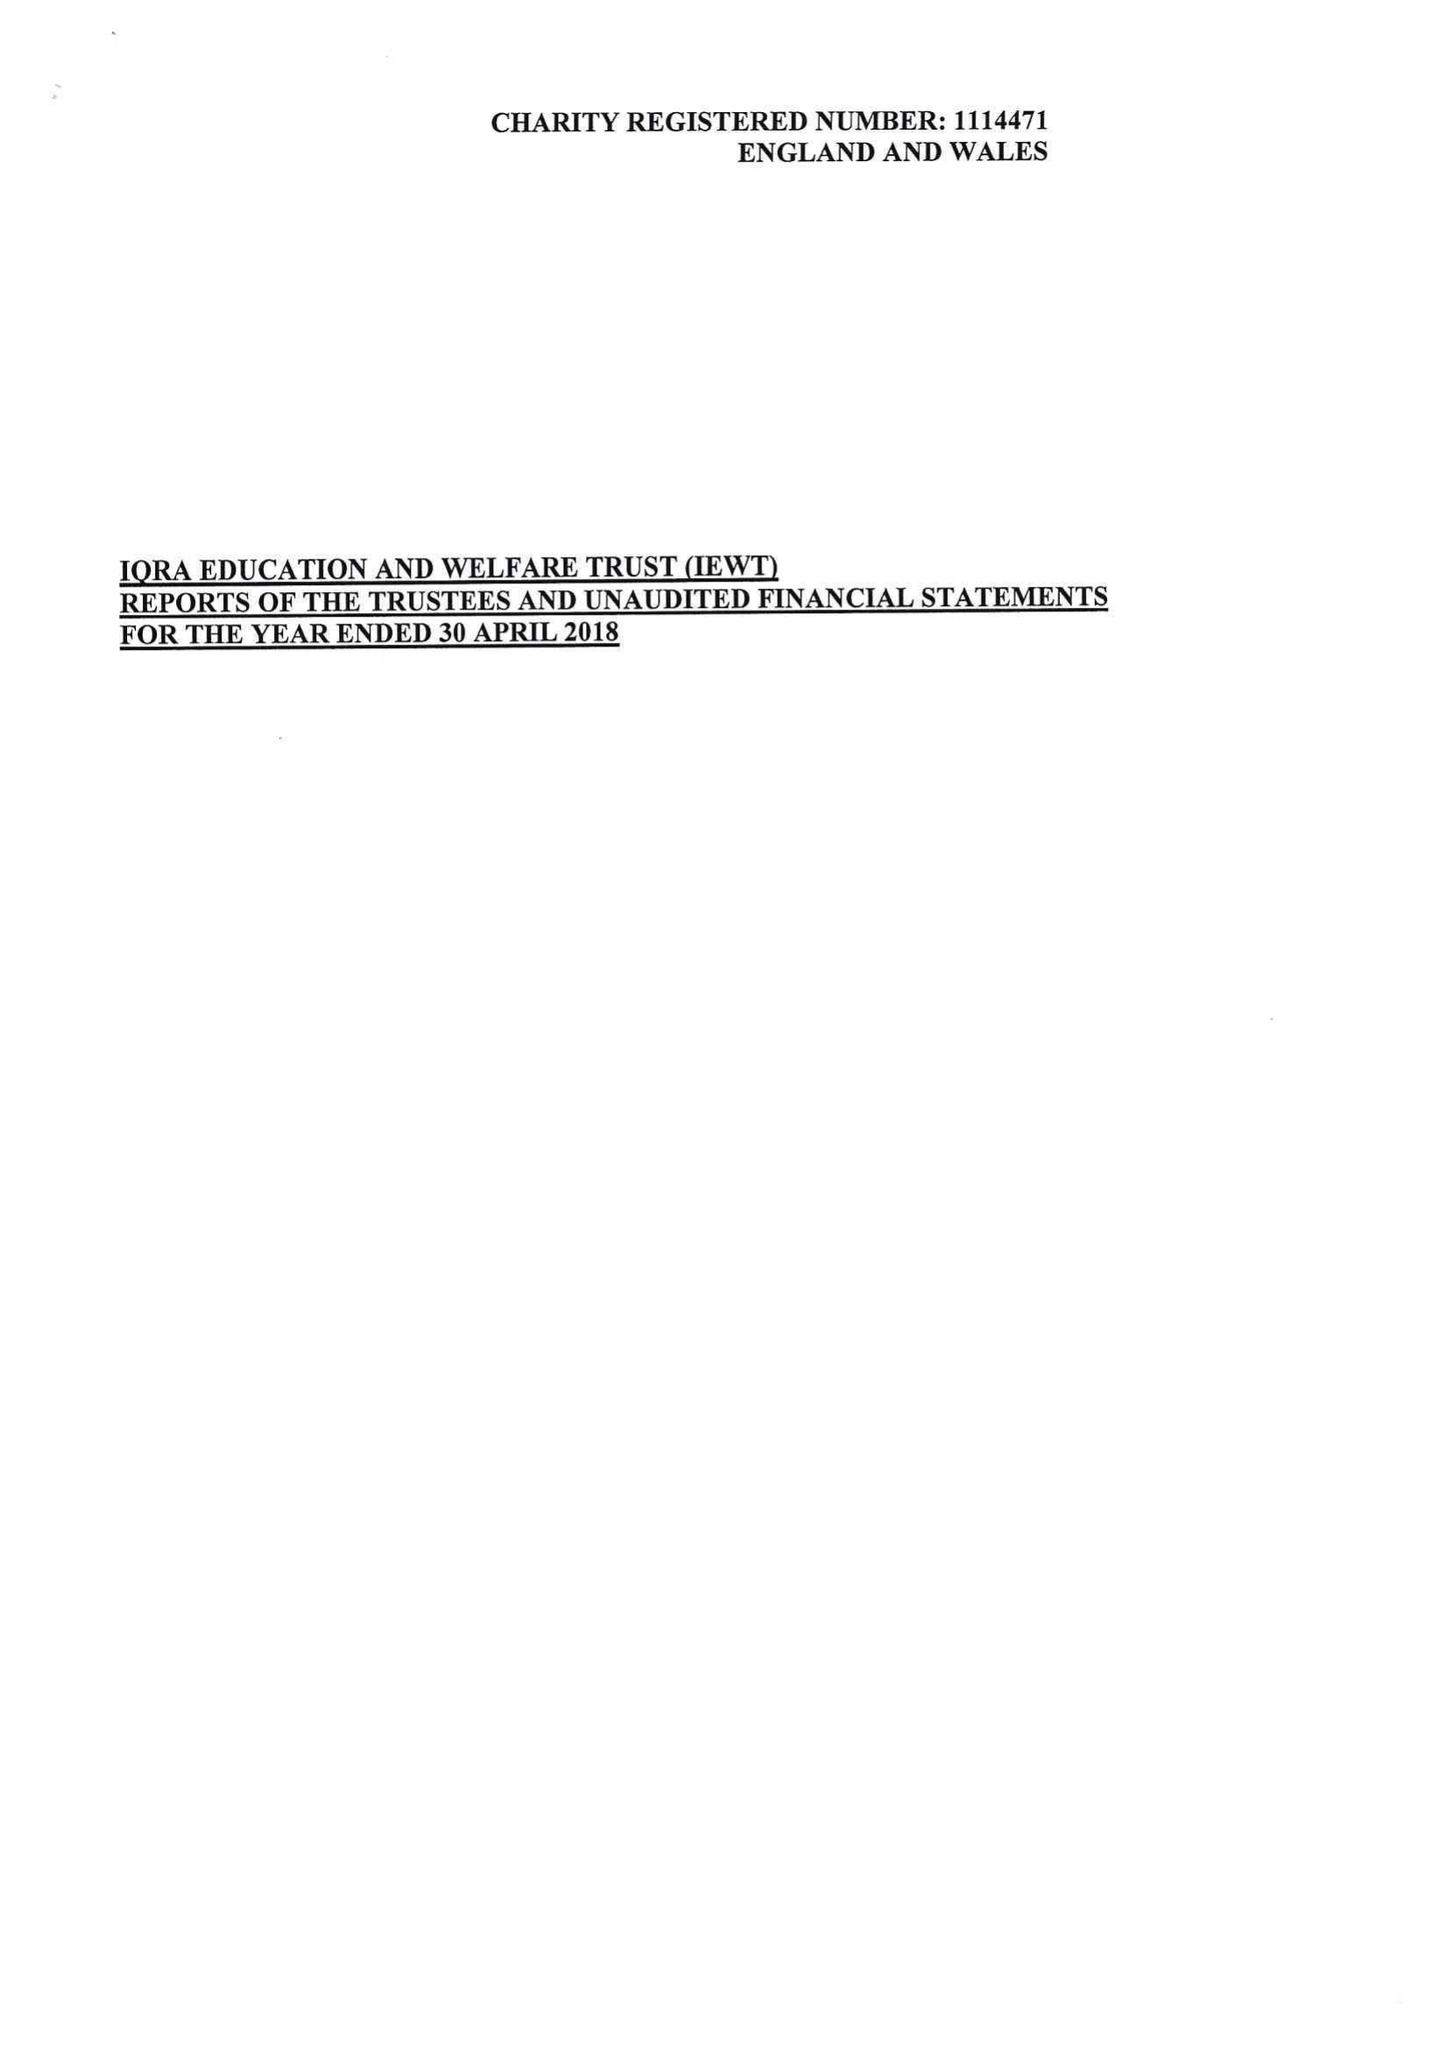What is the value for the address__postcode?
Answer the question using a single word or phrase. OL4 1ER 